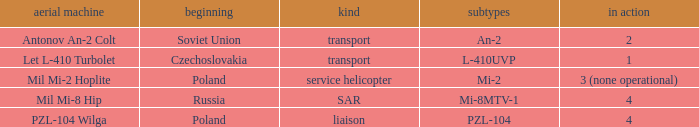Tell me the service for versions l-410uvp 1.0. 